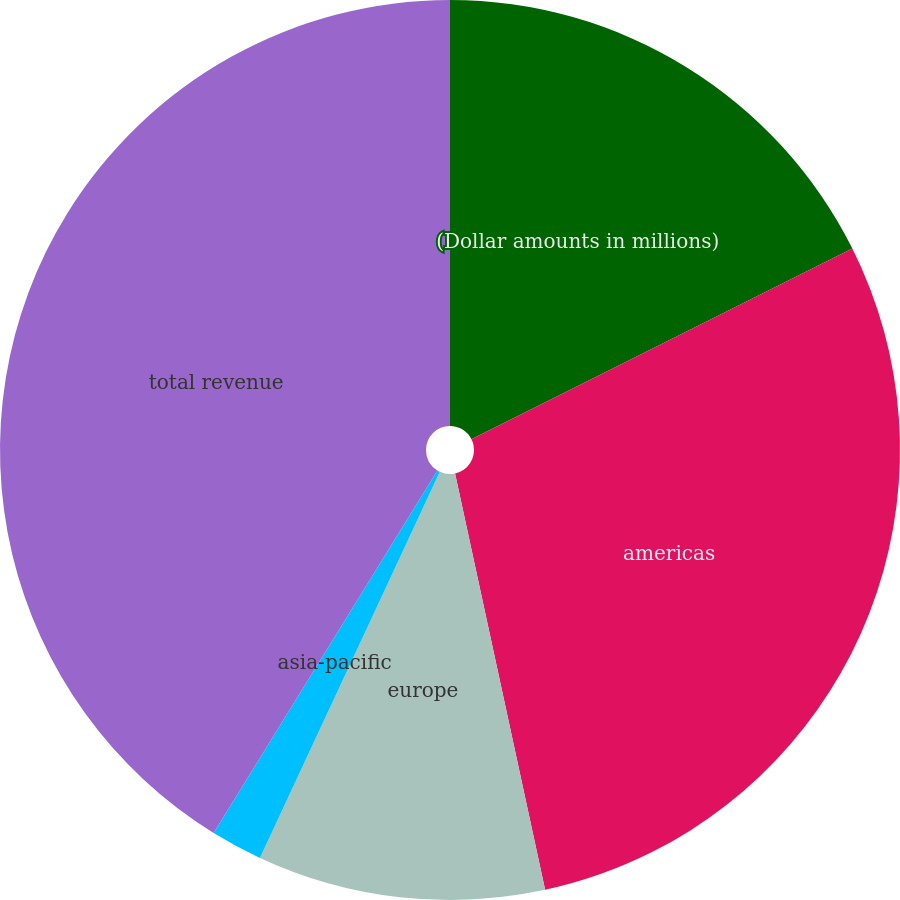Convert chart to OTSL. <chart><loc_0><loc_0><loc_500><loc_500><pie_chart><fcel>(Dollar amounts in millions)<fcel>americas<fcel>europe<fcel>asia-pacific<fcel>total revenue<nl><fcel>17.61%<fcel>29.0%<fcel>10.33%<fcel>1.86%<fcel>41.2%<nl></chart> 